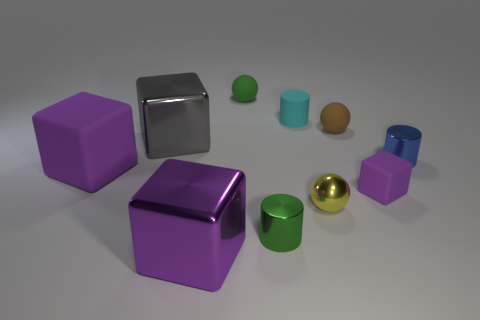What number of other objects are there of the same color as the small block?
Offer a very short reply. 2. What material is the yellow thing?
Your answer should be compact. Metal. What is the small cylinder that is in front of the small brown sphere and to the left of the tiny cube made of?
Give a very brief answer. Metal. How many things are either spheres that are left of the small brown object or green metallic cylinders?
Your answer should be compact. 3. Do the small cube and the tiny shiny sphere have the same color?
Your answer should be compact. No. Is there a metal thing of the same size as the brown matte sphere?
Keep it short and to the point. Yes. How many things are both in front of the large gray metal thing and on the right side of the green rubber ball?
Give a very brief answer. 4. There is a tiny green cylinder; how many yellow metallic balls are to the left of it?
Keep it short and to the point. 0. Is there a yellow shiny object that has the same shape as the small cyan matte thing?
Give a very brief answer. No. Does the cyan thing have the same shape as the big metal thing that is in front of the big gray block?
Provide a short and direct response. No. 